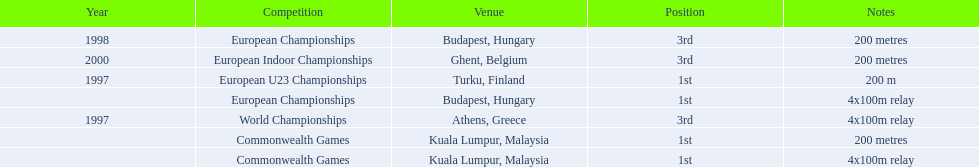How long was the sprint from the european indoor championships competition in 2000? 200 metres. 